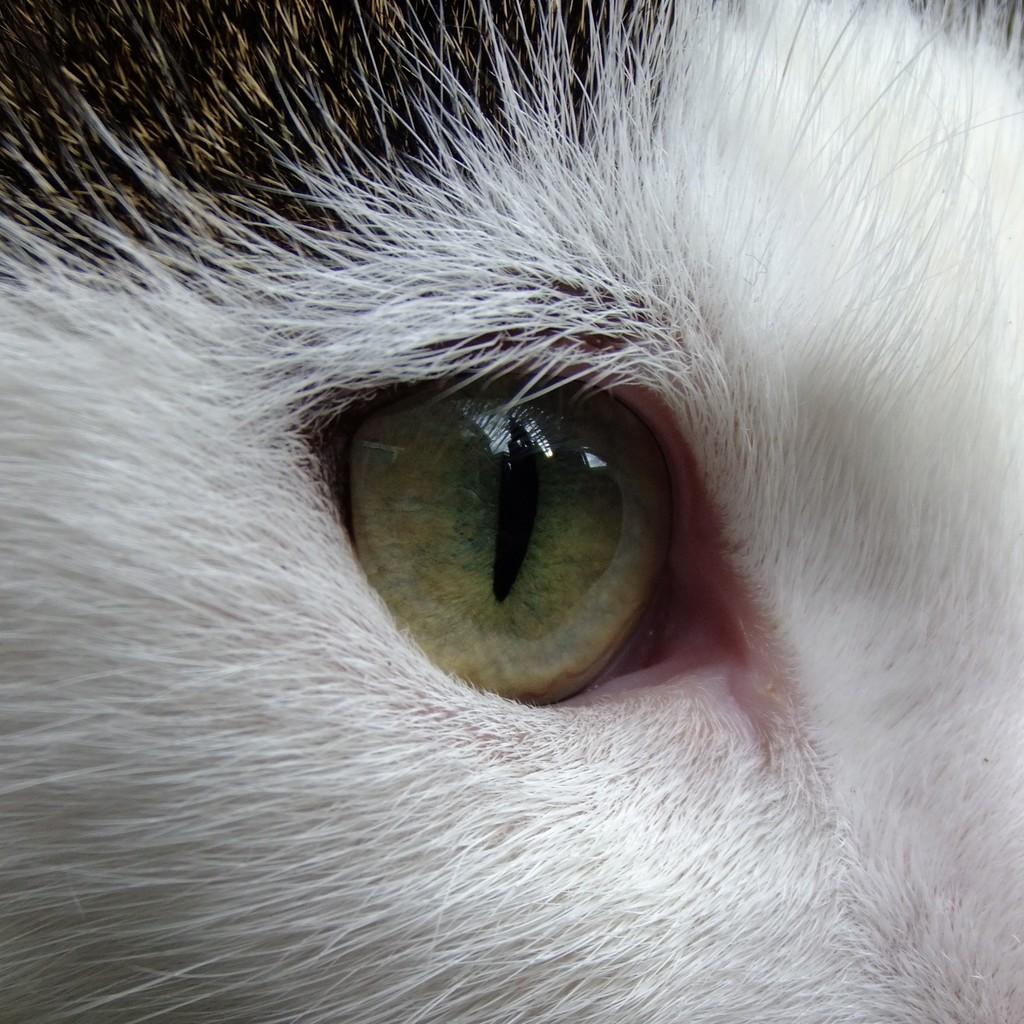What is the main subject of the image? The main subject of the image is a close picture of an animal. Can you describe the animal in the image? Unfortunately, the provided facts do not include any details about the animal's appearance or species. What is the animal's profit from the fifth business venture? There is no information about the animal's business ventures or profits in the image. 